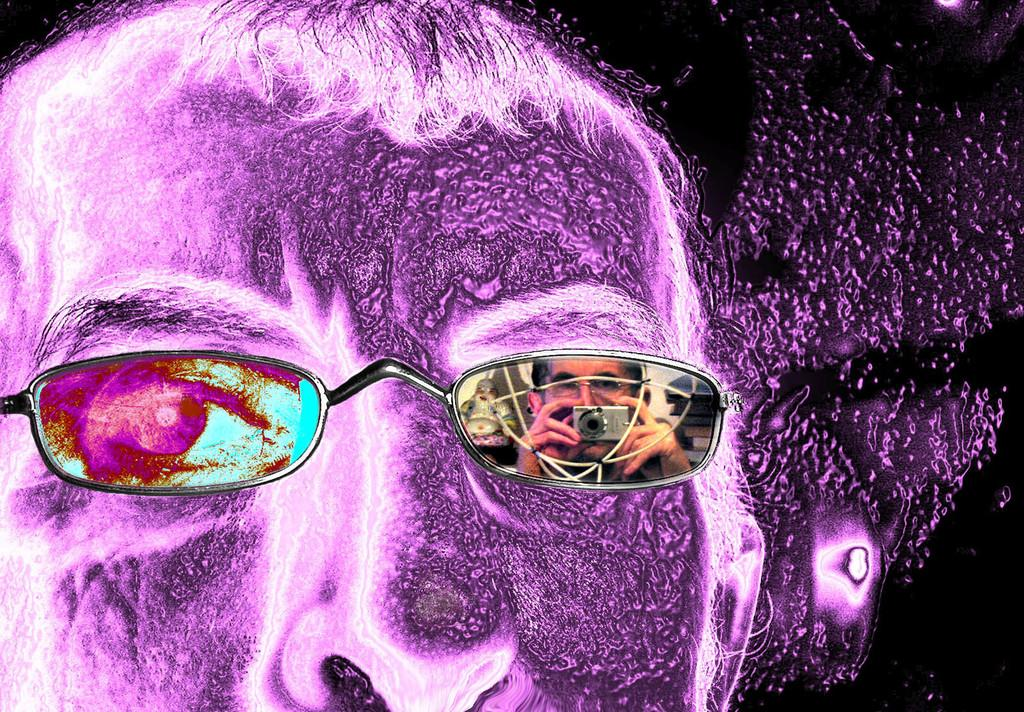What type of image is being described? The image is an animated picture. What objects can be seen in the image? There are spectacles in the image. What detail can be observed about the spectacles? The spectacles have a reflection of a person holding a camera. How many toys are visible in the image? There are no toys present in the image; it features spectacles with a reflection of a person holding a camera. Is there a group of people in the image? The image only shows spectacles with a reflection of a person holding a camera, so there is no group of people present. 